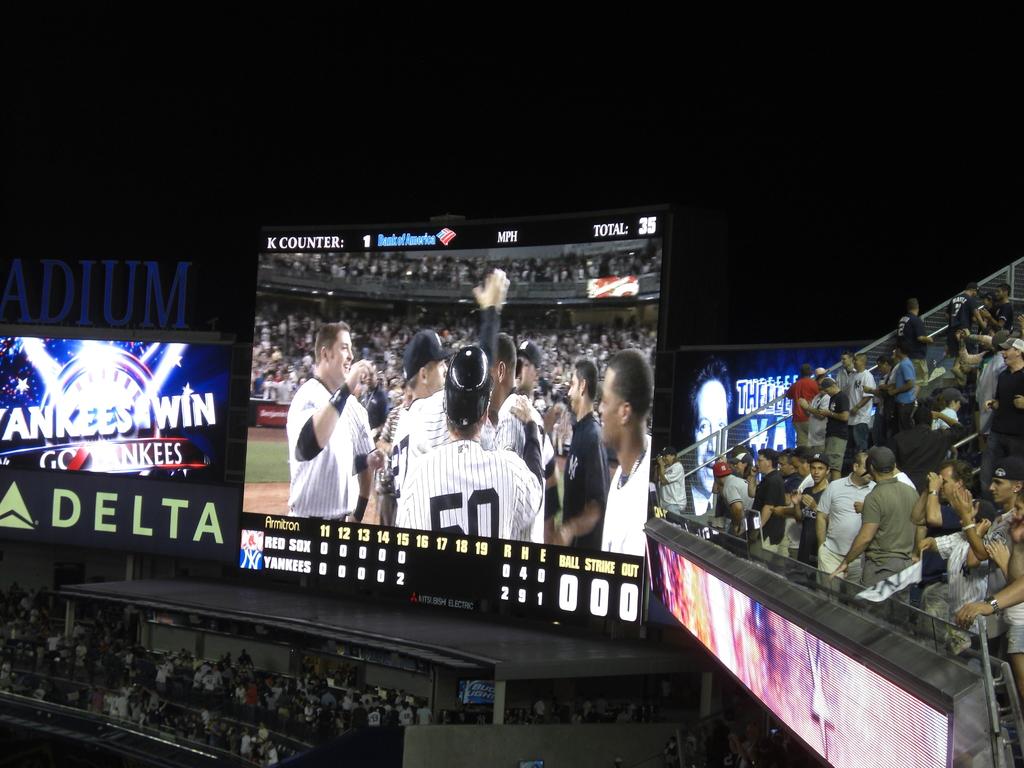What major airlines is next to the scoreboard?
Give a very brief answer. Delta. What team name is mentioned to the left?
Make the answer very short. Yankees. 